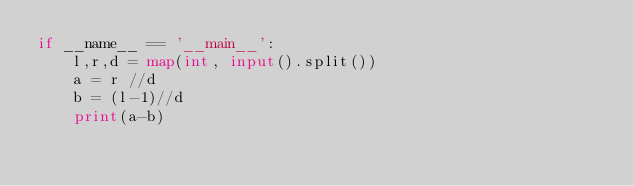Convert code to text. <code><loc_0><loc_0><loc_500><loc_500><_Python_>if __name__ == '__main__':
    l,r,d = map(int, input().split())
    a = r //d
    b = (l-1)//d
    print(a-b)
</code> 